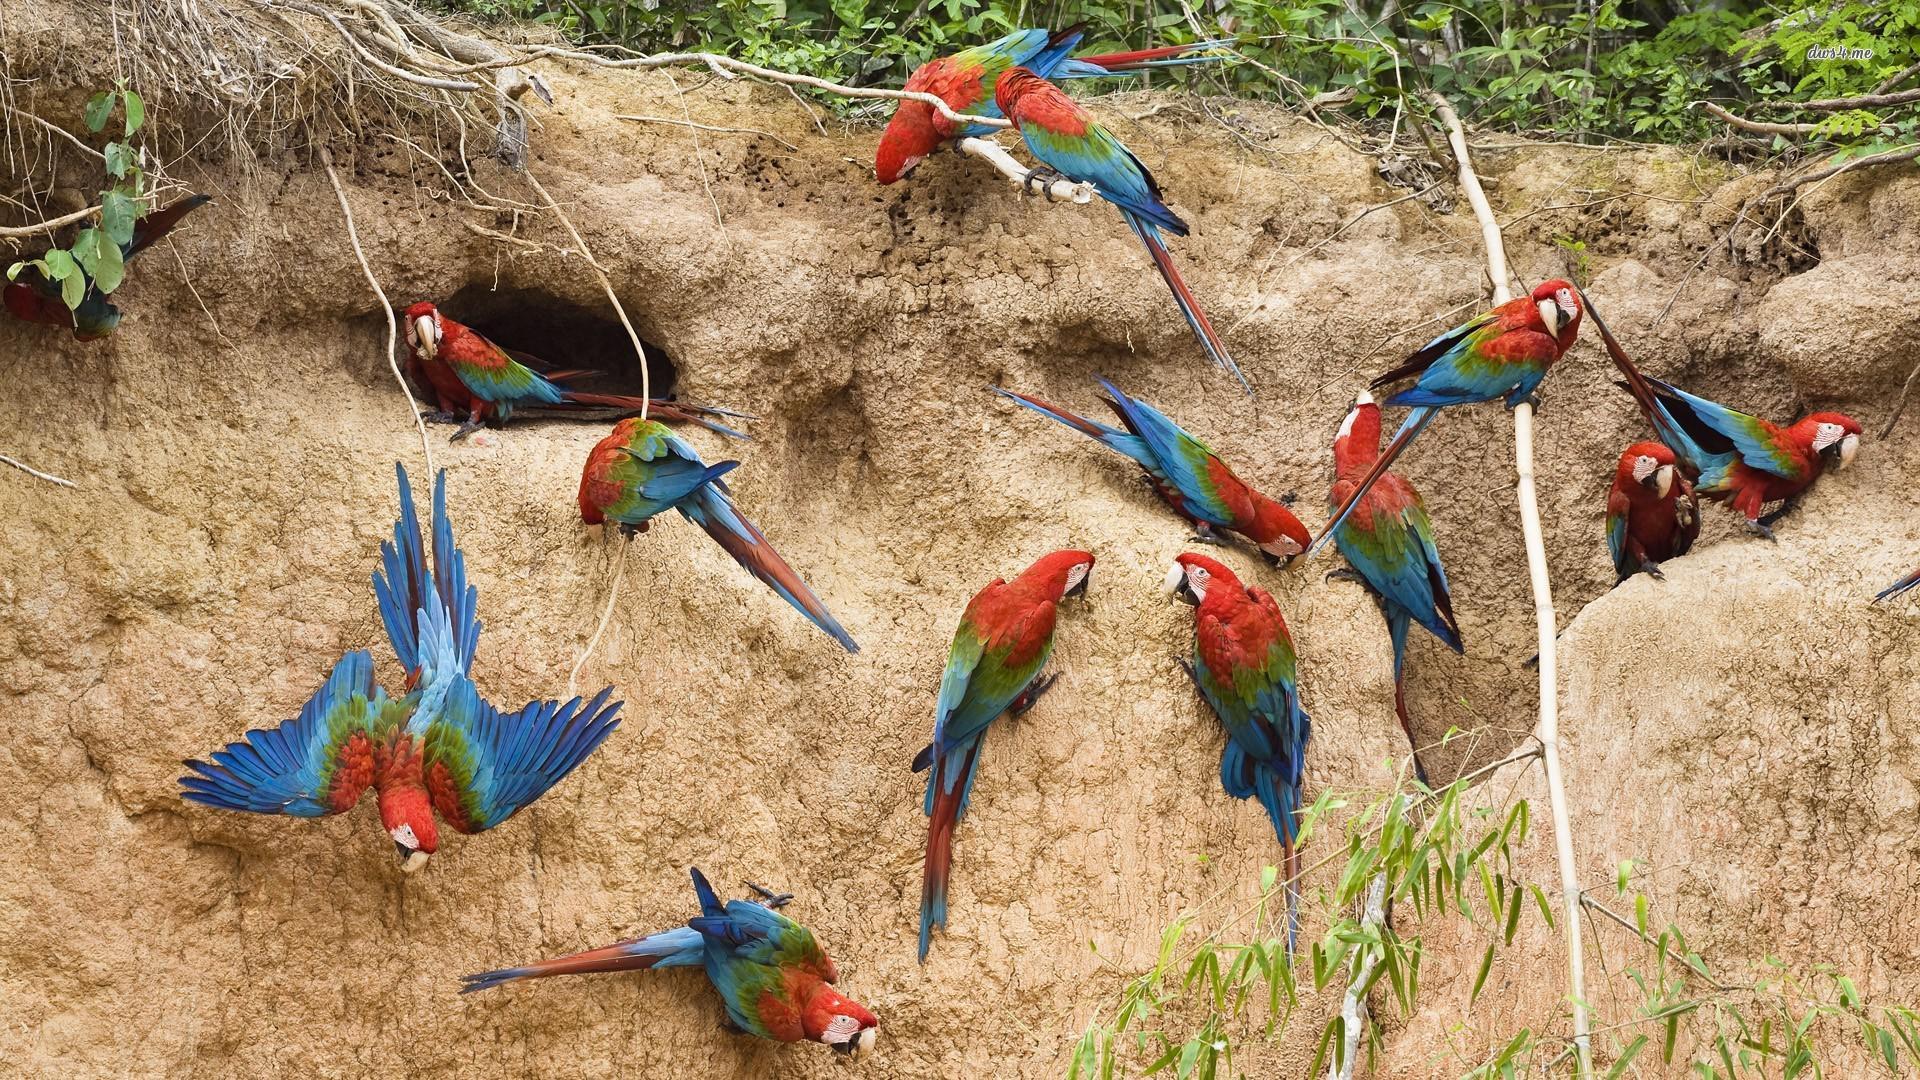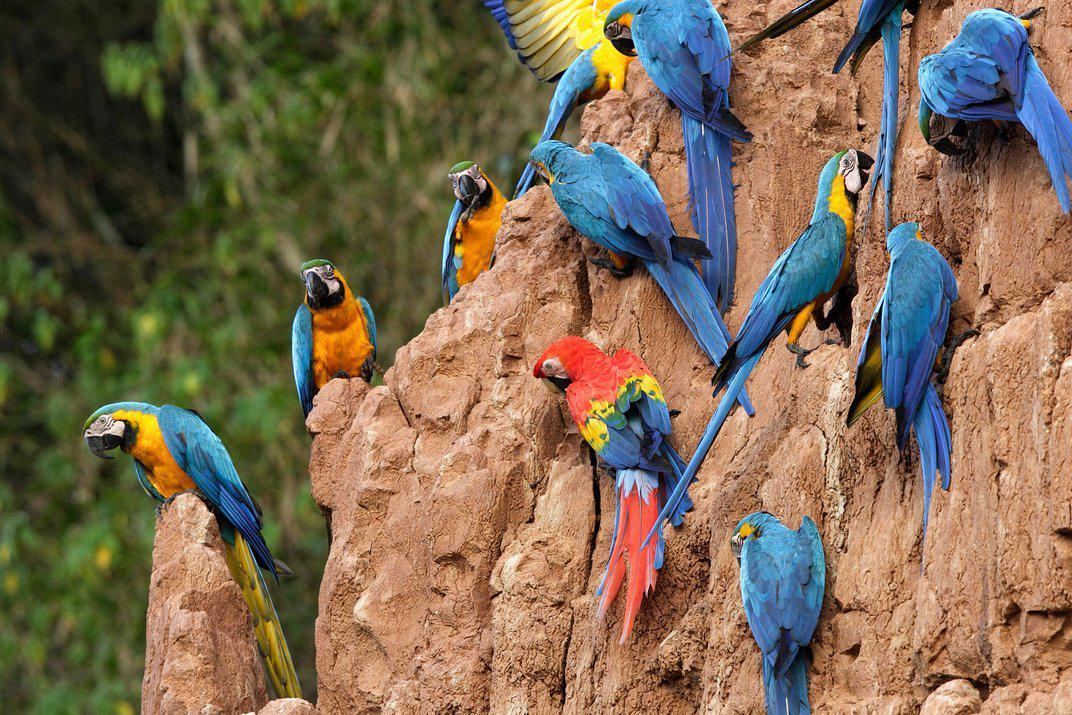The first image is the image on the left, the second image is the image on the right. Given the left and right images, does the statement "There are a large number of parrots perched on a rocky wall." hold true? Answer yes or no. Yes. 